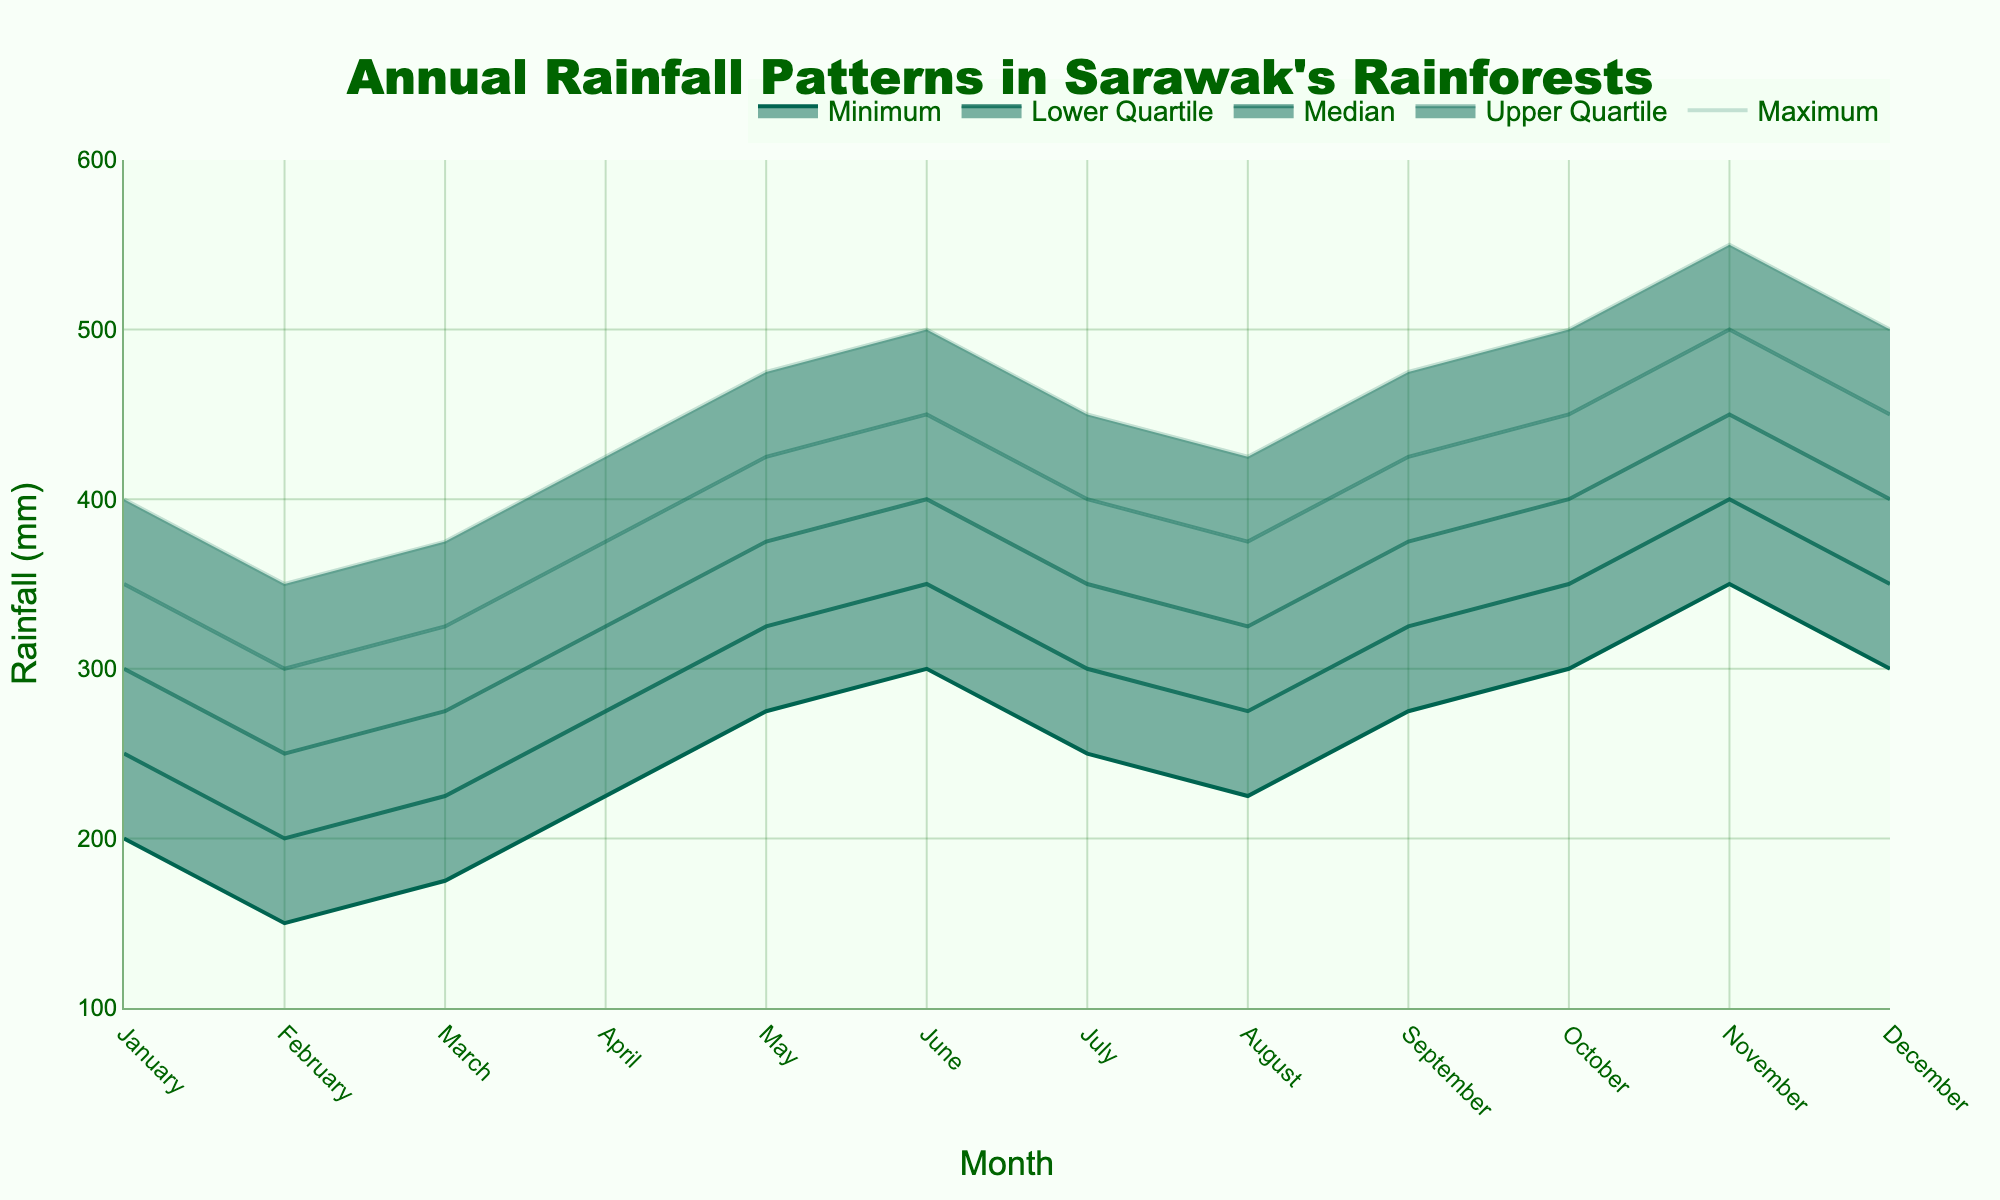What is the title of the chart? The title is always shown at the top of the chart. In this case, it is centered at the top of the figure.
Answer: Annual Rainfall Patterns in Sarawak's Rainforests Which month has the lowest minimum rainfall? To find this, look for the month with the smallest value in the Minimum rainfall series. This can be observed as the bottom-most line on the chart. In this case, February has the lowest minimum rainfall at 150 mm.
Answer: February What is the median rainfall in June? Look at the central line in the fan chart for June, which represents the median value. For June, the median rainfall is indicated as 400 mm.
Answer: 400 mm What is the range of rainfall (difference between maximum and minimum) in October? Subtract the minimum rainfall value of October from the maximum rainfall value of October. The values are 500 mm and 300 mm respectively, so the range is 500 - 300 = 200.
Answer: 200 mm In which months is the upper quartile rainfall 400 mm? The upper quartile value (third quartile) is 400 mm in the chart where the second darkest shade meets 400 mm on the y-axis. This appears for January, July, October, and December.
Answer: January, July, October, December Does August have a higher median rainfall than April? Compare the median values for both months. April's median rainfall is 325 mm, and August’s is the same at 325 mm.
Answer: No, both are equal By how much does the upper quartile rainfall in November exceed the upper quartile rainfall in May? Subtract the upper quartile rainfall of May from that of November. November's upper quartile is 500 mm, while May's upper quartile is 425 mm. Therefore, the difference is 500 - 425 = 75.
Answer: 75 mm Which month shows the greatest increase in median rainfall compared to the previous month? To find this, calculate the differences between consecutive months' median values and determine the largest difference. March to April: 325 - 275 = 50, and April to May: 375 - 325 = 50 give the greatest increases.
Answer: April What is the interquartile range (IQR) for rainfall in March? IQR is the difference between the upper and lower quartile values. For March, the upper quartile is 325 mm and the lower quartile is 225 mm. Thus, IQR is 325 - 225 = 100.
Answer: 100 mm In which month is the median rainfall the highest? Look at the topmost central line (median line) and find the month where this line reaches the highest point on the y-axis. November has the highest median rainfall at 450 mm.
Answer: November 